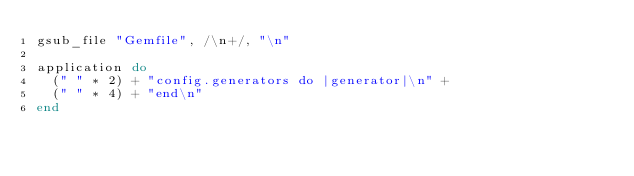<code> <loc_0><loc_0><loc_500><loc_500><_Ruby_>gsub_file "Gemfile", /\n+/, "\n"

application do
  (" " * 2) + "config.generators do |generator|\n" +
  (" " * 4) + "end\n"
end
</code> 